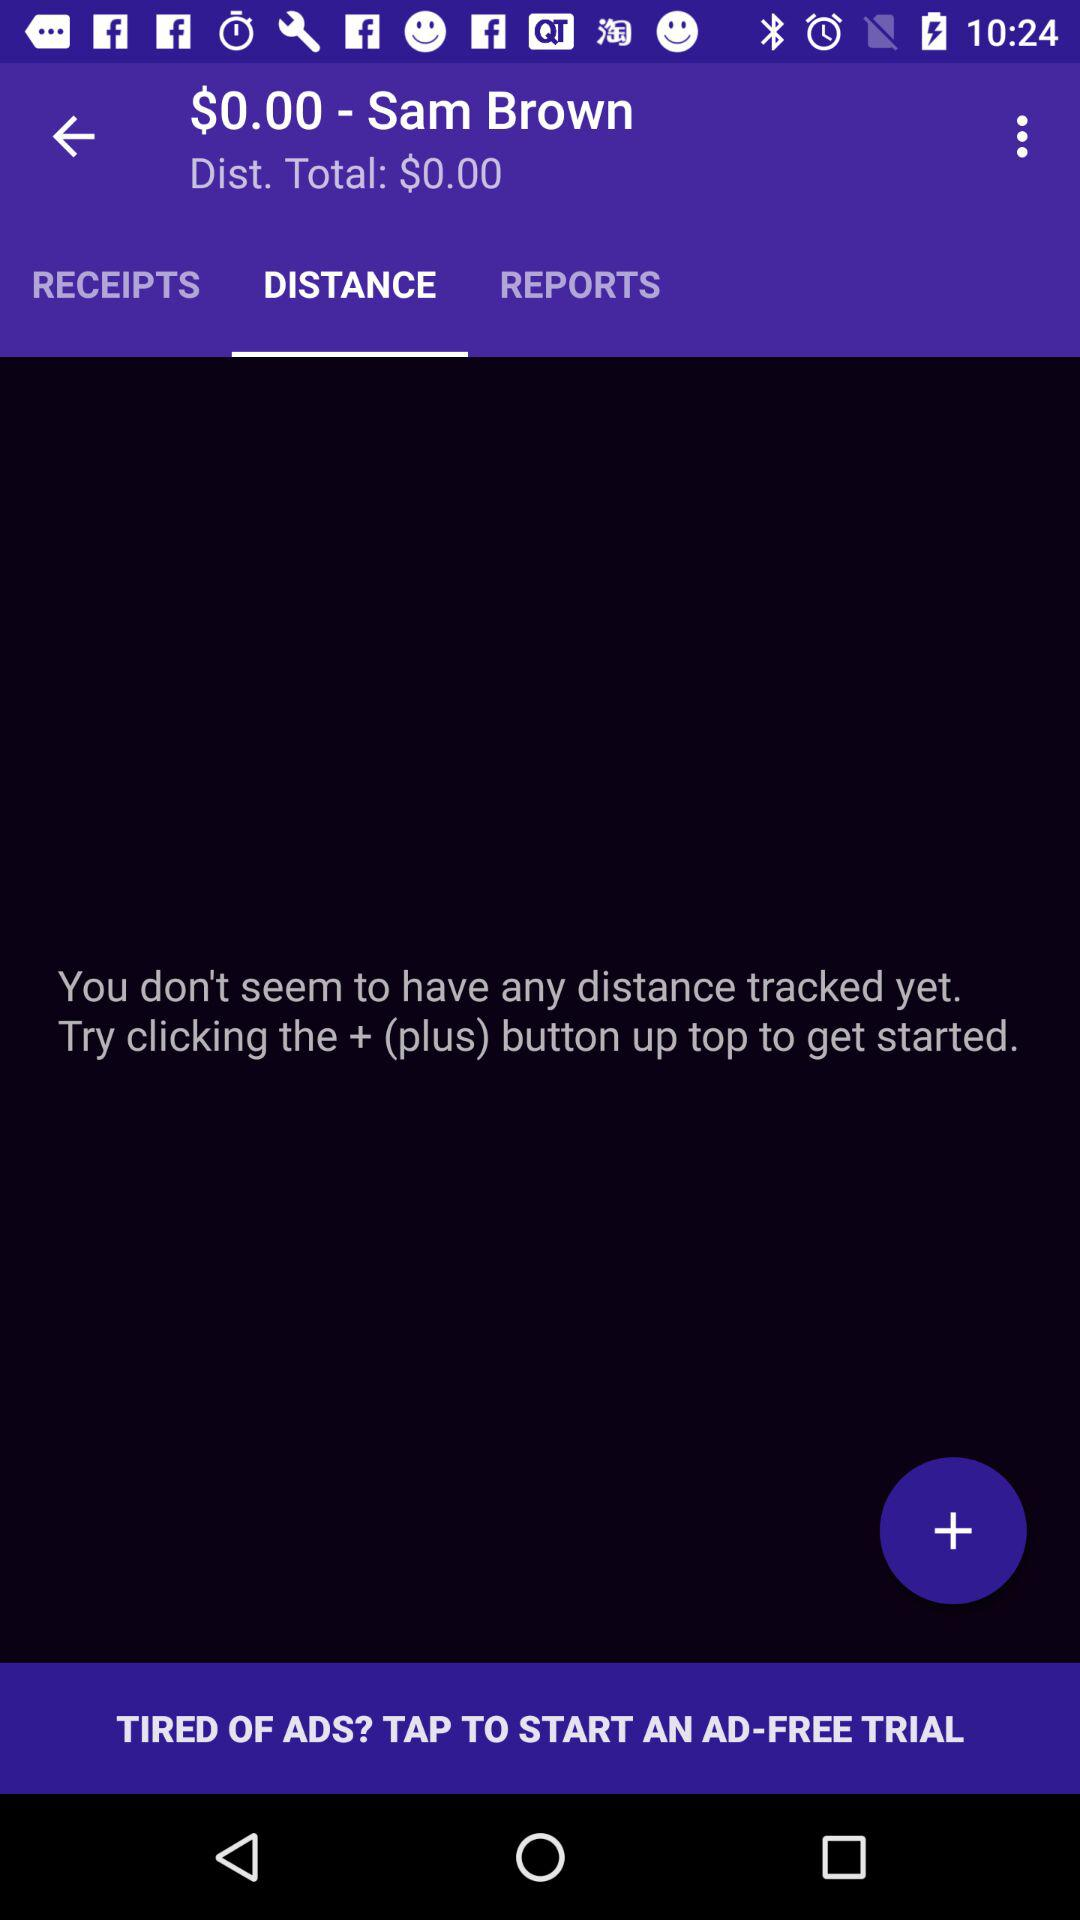Which tab is selected? The selected tab is "DISTANCE". 